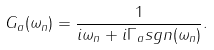<formula> <loc_0><loc_0><loc_500><loc_500>G _ { a } ( \omega _ { n } ) = \frac { 1 } { i \omega _ { n } + i \Gamma _ { a } s g n ( \omega _ { n } ) } .</formula> 